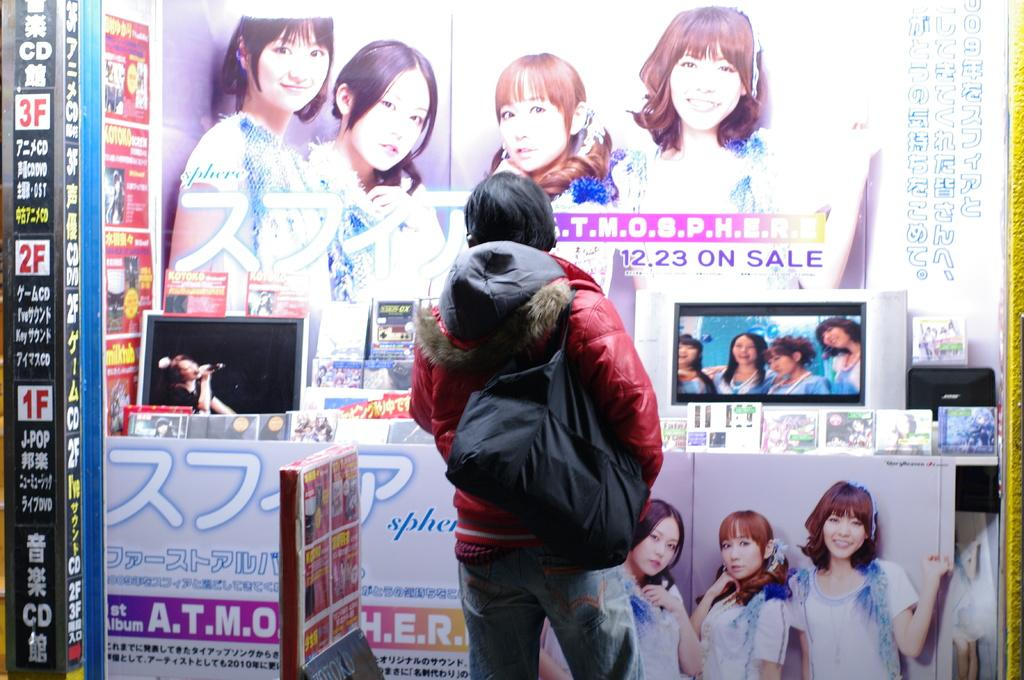Who or what is present in the image? There is a person in the image. What is the person wearing? The person is wearing a bag. What is in front of the person? There are monitors, posters, and other objects visible in front of the person. How does the person smash the hole in the image? There is no hole or smashing action present in the image. 